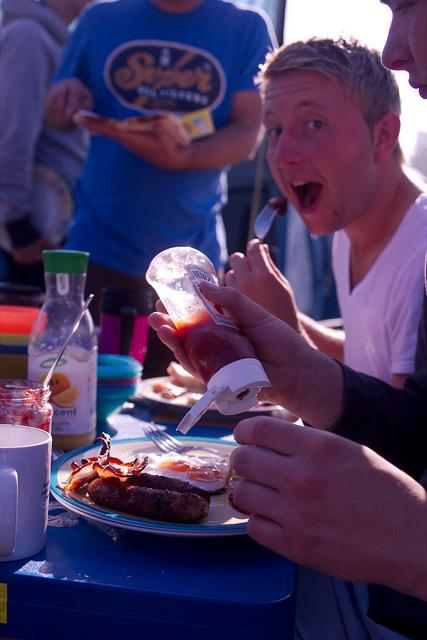Why are the men seated? Please explain your reasoning. to eat. The men are trying to eat. 